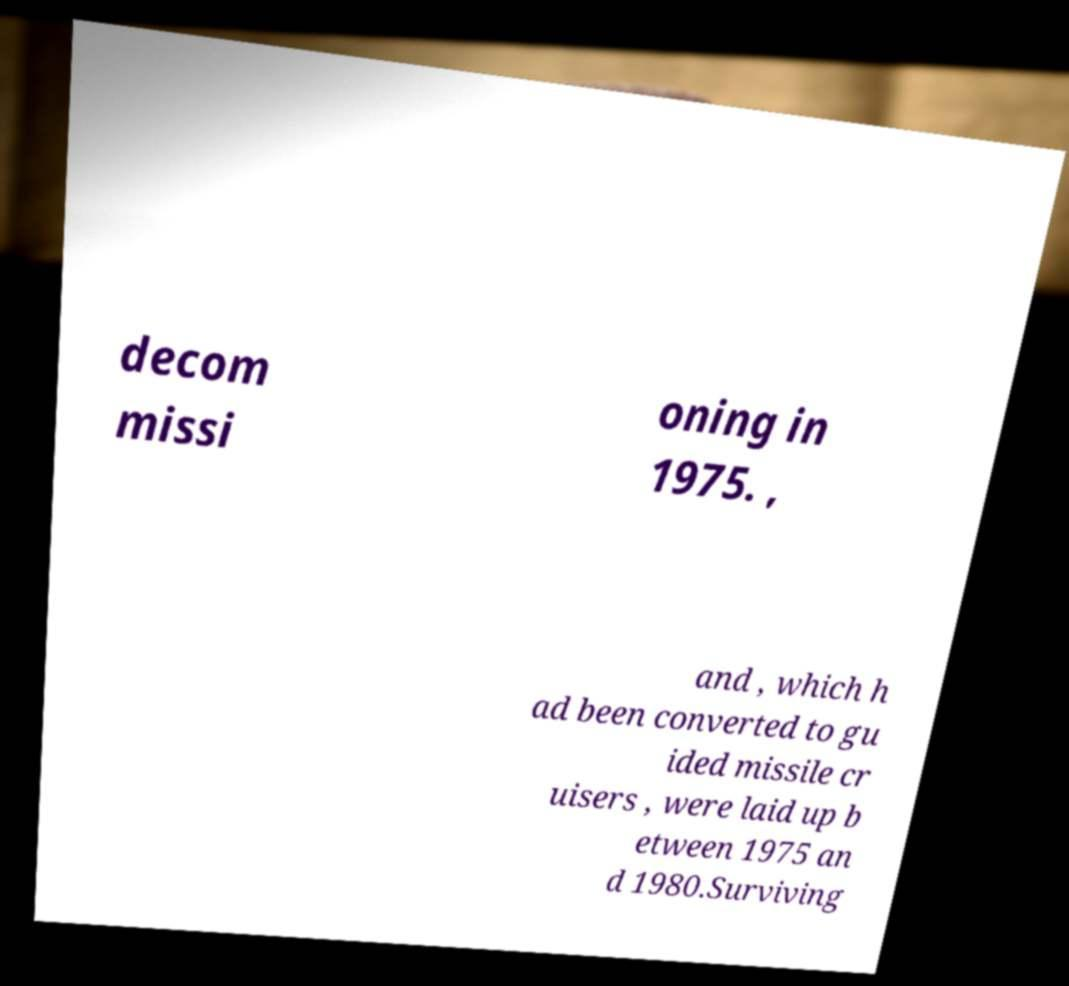Could you assist in decoding the text presented in this image and type it out clearly? decom missi oning in 1975. , and , which h ad been converted to gu ided missile cr uisers , were laid up b etween 1975 an d 1980.Surviving 